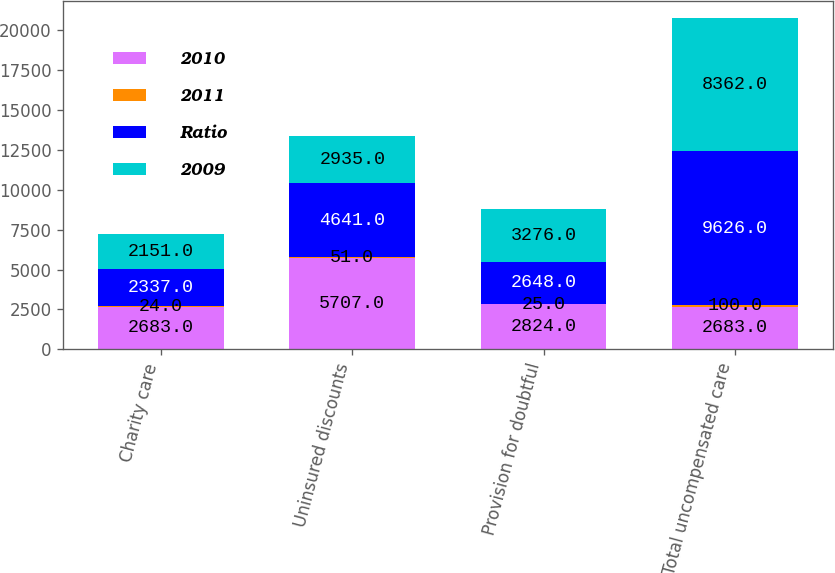Convert chart to OTSL. <chart><loc_0><loc_0><loc_500><loc_500><stacked_bar_chart><ecel><fcel>Charity care<fcel>Uninsured discounts<fcel>Provision for doubtful<fcel>Total uncompensated care<nl><fcel>2010<fcel>2683<fcel>5707<fcel>2824<fcel>2683<nl><fcel>2011<fcel>24<fcel>51<fcel>25<fcel>100<nl><fcel>Ratio<fcel>2337<fcel>4641<fcel>2648<fcel>9626<nl><fcel>2009<fcel>2151<fcel>2935<fcel>3276<fcel>8362<nl></chart> 